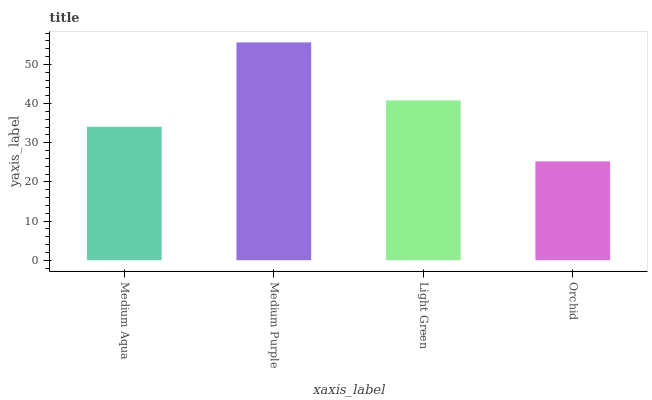Is Orchid the minimum?
Answer yes or no. Yes. Is Medium Purple the maximum?
Answer yes or no. Yes. Is Light Green the minimum?
Answer yes or no. No. Is Light Green the maximum?
Answer yes or no. No. Is Medium Purple greater than Light Green?
Answer yes or no. Yes. Is Light Green less than Medium Purple?
Answer yes or no. Yes. Is Light Green greater than Medium Purple?
Answer yes or no. No. Is Medium Purple less than Light Green?
Answer yes or no. No. Is Light Green the high median?
Answer yes or no. Yes. Is Medium Aqua the low median?
Answer yes or no. Yes. Is Orchid the high median?
Answer yes or no. No. Is Medium Purple the low median?
Answer yes or no. No. 